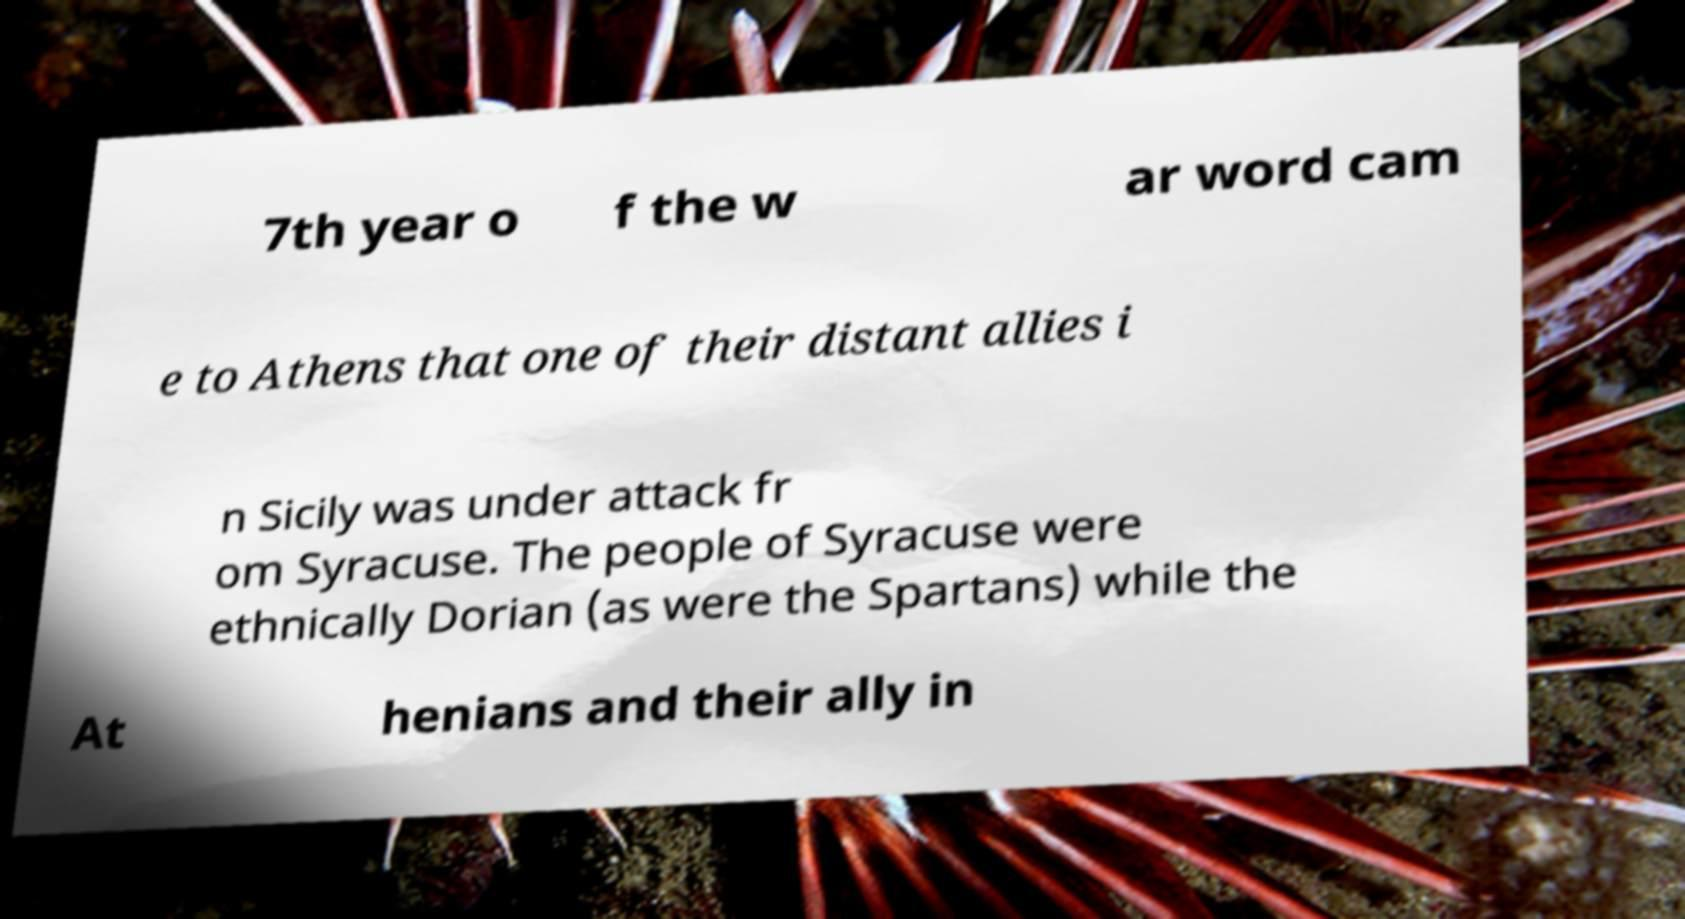Can you read and provide the text displayed in the image?This photo seems to have some interesting text. Can you extract and type it out for me? 7th year o f the w ar word cam e to Athens that one of their distant allies i n Sicily was under attack fr om Syracuse. The people of Syracuse were ethnically Dorian (as were the Spartans) while the At henians and their ally in 